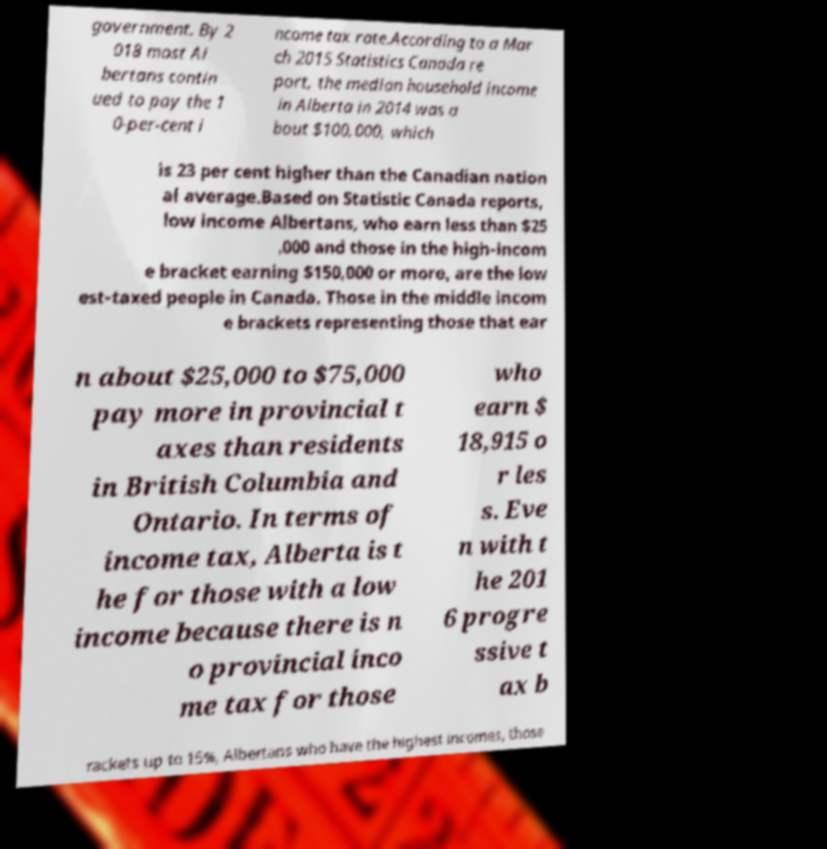For documentation purposes, I need the text within this image transcribed. Could you provide that? government. By 2 018 most Al bertans contin ued to pay the 1 0-per-cent i ncome tax rate.According to a Mar ch 2015 Statistics Canada re port, the median household income in Alberta in 2014 was a bout $100,000, which is 23 per cent higher than the Canadian nation al average.Based on Statistic Canada reports, low income Albertans, who earn less than $25 ,000 and those in the high-incom e bracket earning $150,000 or more, are the low est-taxed people in Canada. Those in the middle incom e brackets representing those that ear n about $25,000 to $75,000 pay more in provincial t axes than residents in British Columbia and Ontario. In terms of income tax, Alberta is t he for those with a low income because there is n o provincial inco me tax for those who earn $ 18,915 o r les s. Eve n with t he 201 6 progre ssive t ax b rackets up to 15%, Albertans who have the highest incomes, those 